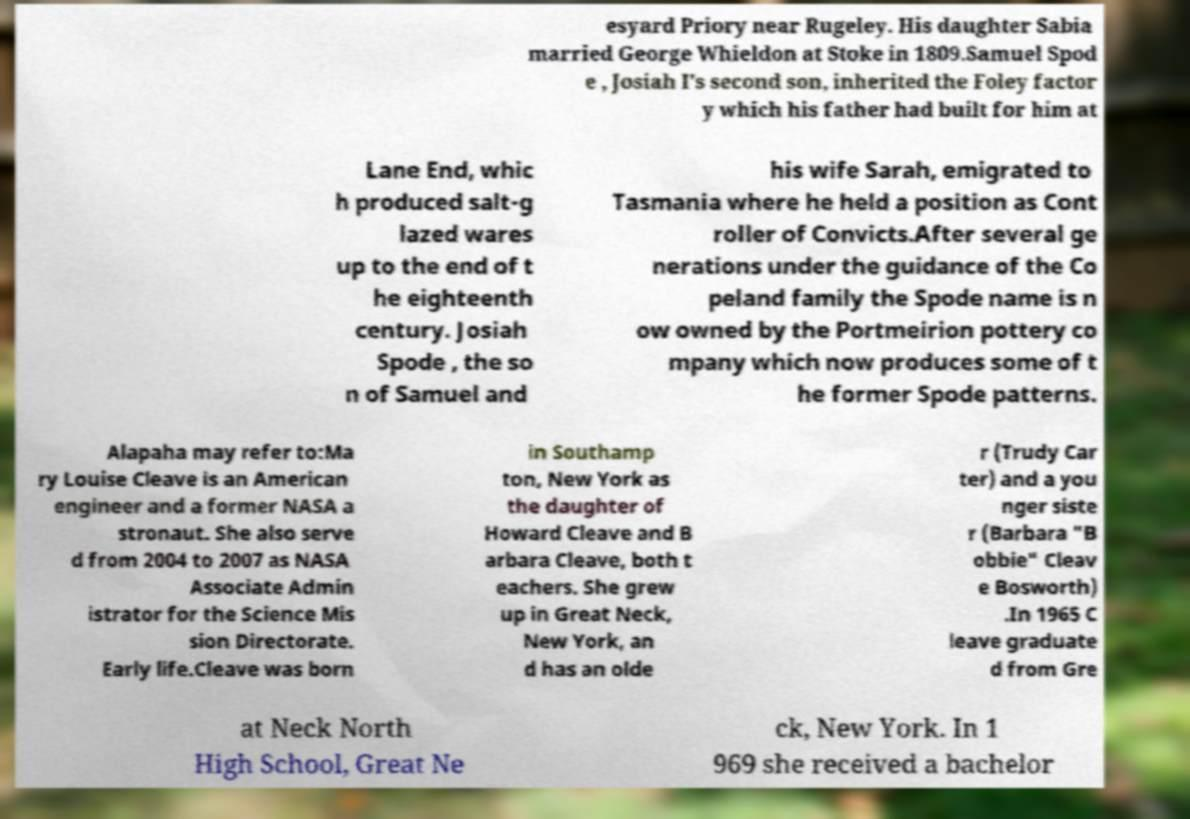For documentation purposes, I need the text within this image transcribed. Could you provide that? esyard Priory near Rugeley. His daughter Sabia married George Whieldon at Stoke in 1809.Samuel Spod e , Josiah I's second son, inherited the Foley factor y which his father had built for him at Lane End, whic h produced salt-g lazed wares up to the end of t he eighteenth century. Josiah Spode , the so n of Samuel and his wife Sarah, emigrated to Tasmania where he held a position as Cont roller of Convicts.After several ge nerations under the guidance of the Co peland family the Spode name is n ow owned by the Portmeirion pottery co mpany which now produces some of t he former Spode patterns. Alapaha may refer to:Ma ry Louise Cleave is an American engineer and a former NASA a stronaut. She also serve d from 2004 to 2007 as NASA Associate Admin istrator for the Science Mis sion Directorate. Early life.Cleave was born in Southamp ton, New York as the daughter of Howard Cleave and B arbara Cleave, both t eachers. She grew up in Great Neck, New York, an d has an olde r (Trudy Car ter) and a you nger siste r (Barbara "B obbie" Cleav e Bosworth) .In 1965 C leave graduate d from Gre at Neck North High School, Great Ne ck, New York. In 1 969 she received a bachelor 